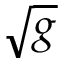Convert formula to latex. <formula><loc_0><loc_0><loc_500><loc_500>\sqrt { g }</formula> 